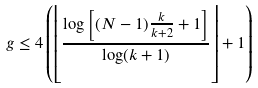<formula> <loc_0><loc_0><loc_500><loc_500>g \leq 4 \left ( \left \lfloor \frac { \log \left [ ( N - 1 ) \frac { k } { k + 2 } + 1 \right ] } { \log ( k + 1 ) } \right \rfloor + 1 \right )</formula> 